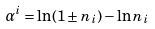Convert formula to latex. <formula><loc_0><loc_0><loc_500><loc_500>\alpha ^ { i } = \ln ( 1 \pm n _ { i } ) - \ln n _ { i }</formula> 